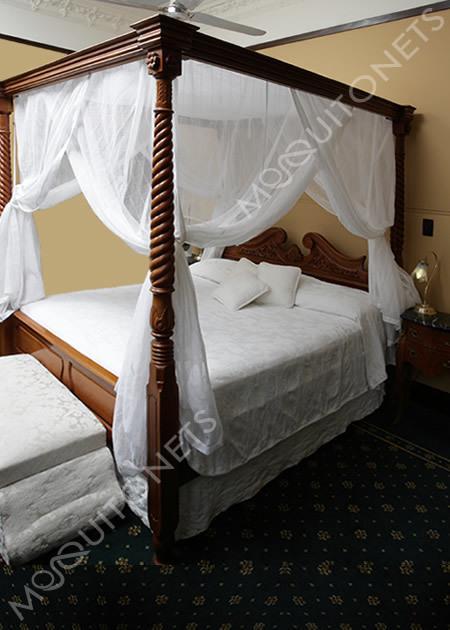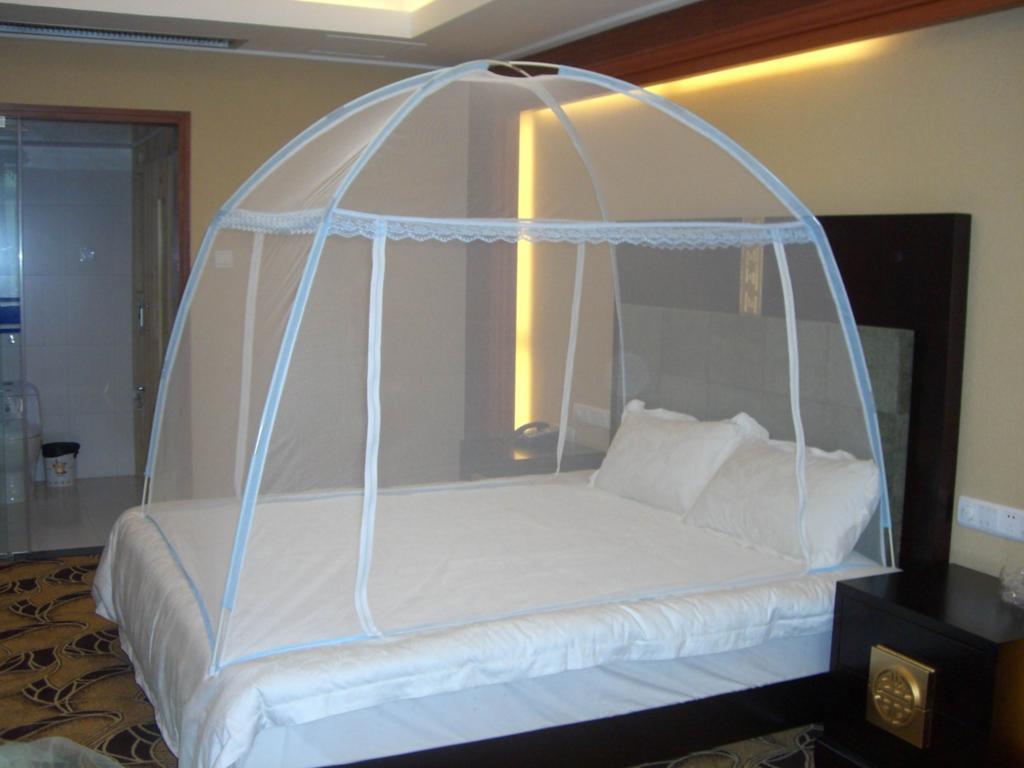The first image is the image on the left, the second image is the image on the right. Assess this claim about the two images: "Exactly one bed has corner posts.". Correct or not? Answer yes or no. Yes. The first image is the image on the left, the second image is the image on the right. For the images displayed, is the sentence "The bed in the image on the right is covered by a curved tent." factually correct? Answer yes or no. Yes. 